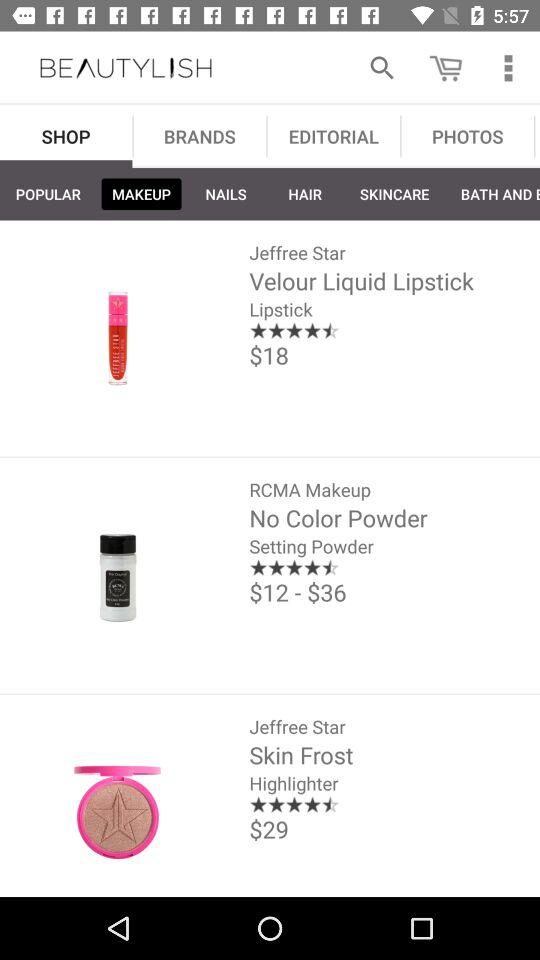What is the price of "Skin Frost"? The price is $29. 